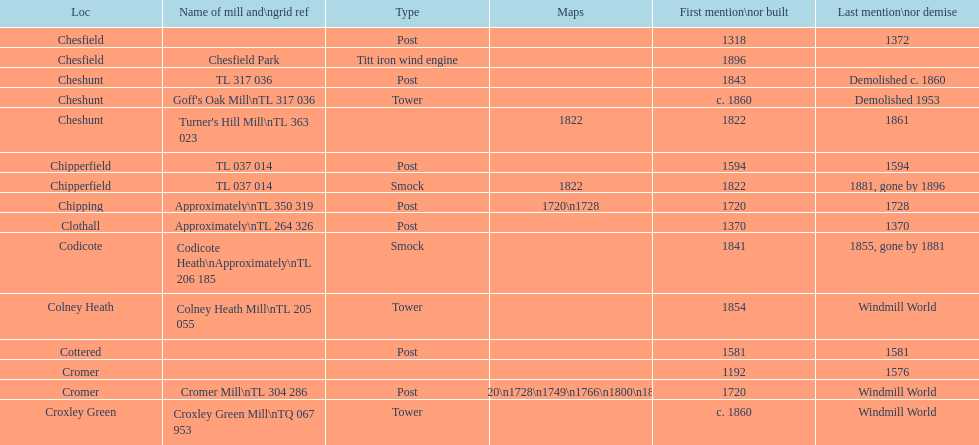After 1800, how many mills were constructed or initially mentioned? 8. 